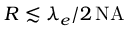Convert formula to latex. <formula><loc_0><loc_0><loc_500><loc_500>R \lesssim \lambda _ { e } / 2 \, N A</formula> 